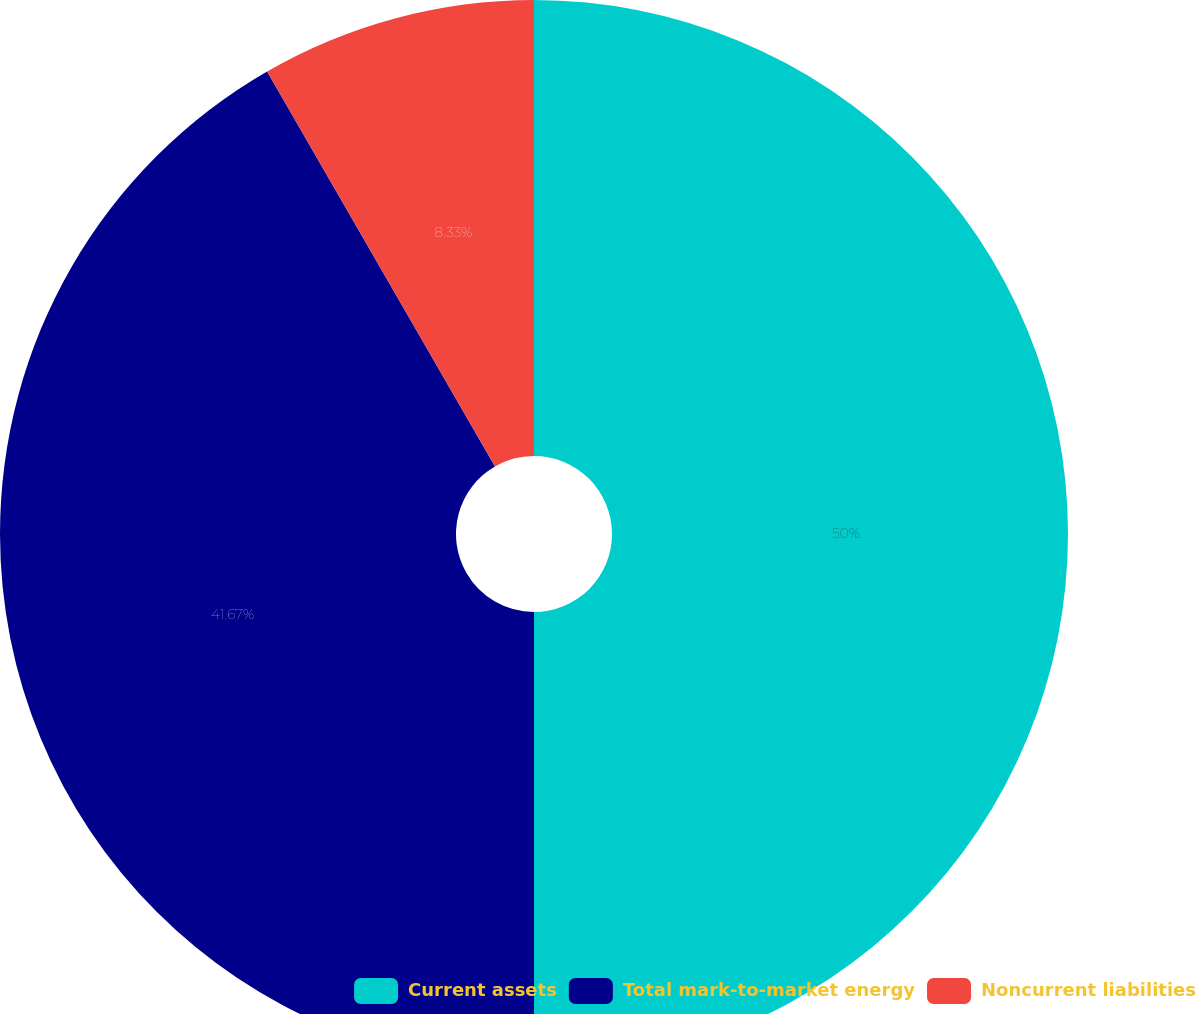<chart> <loc_0><loc_0><loc_500><loc_500><pie_chart><fcel>Current assets<fcel>Total mark-to-market energy<fcel>Noncurrent liabilities<nl><fcel>50.0%<fcel>41.67%<fcel>8.33%<nl></chart> 